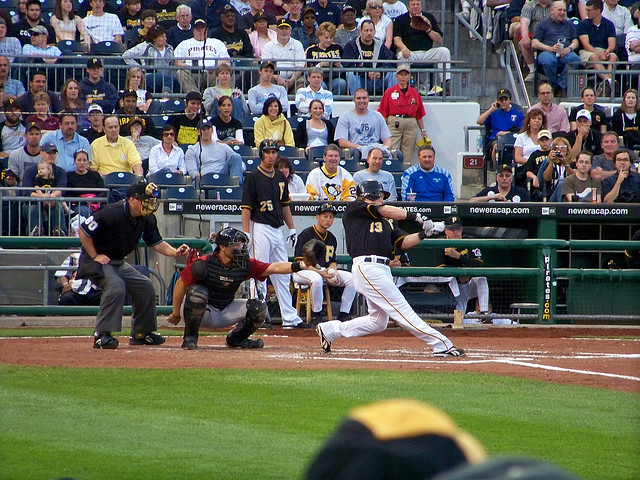Please transcribe the text information in this image. P 13 25 newer neweracap.com 21 